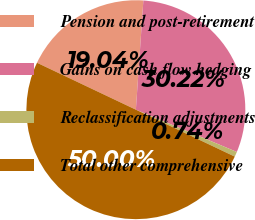Convert chart to OTSL. <chart><loc_0><loc_0><loc_500><loc_500><pie_chart><fcel>Pension and post-retirement<fcel>Gains on cash flow hedging<fcel>Reclassification adjustments<fcel>Total other comprehensive<nl><fcel>19.04%<fcel>30.22%<fcel>0.74%<fcel>50.0%<nl></chart> 